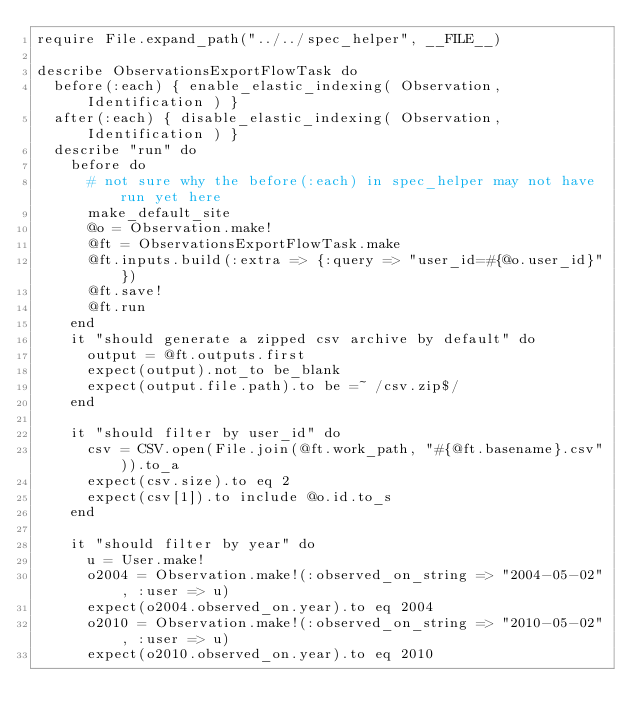Convert code to text. <code><loc_0><loc_0><loc_500><loc_500><_Ruby_>require File.expand_path("../../spec_helper", __FILE__)

describe ObservationsExportFlowTask do
  before(:each) { enable_elastic_indexing( Observation, Identification ) }
  after(:each) { disable_elastic_indexing( Observation, Identification ) }
  describe "run" do
    before do
      # not sure why the before(:each) in spec_helper may not have run yet here
      make_default_site
      @o = Observation.make!
      @ft = ObservationsExportFlowTask.make
      @ft.inputs.build(:extra => {:query => "user_id=#{@o.user_id}"})
      @ft.save!
      @ft.run
    end
    it "should generate a zipped csv archive by default" do
      output = @ft.outputs.first
      expect(output).not_to be_blank
      expect(output.file.path).to be =~ /csv.zip$/
    end

    it "should filter by user_id" do
      csv = CSV.open(File.join(@ft.work_path, "#{@ft.basename}.csv")).to_a
      expect(csv.size).to eq 2
      expect(csv[1]).to include @o.id.to_s
    end

    it "should filter by year" do
      u = User.make!
      o2004 = Observation.make!(:observed_on_string => "2004-05-02", :user => u)
      expect(o2004.observed_on.year).to eq 2004
      o2010 = Observation.make!(:observed_on_string => "2010-05-02", :user => u)
      expect(o2010.observed_on.year).to eq 2010</code> 